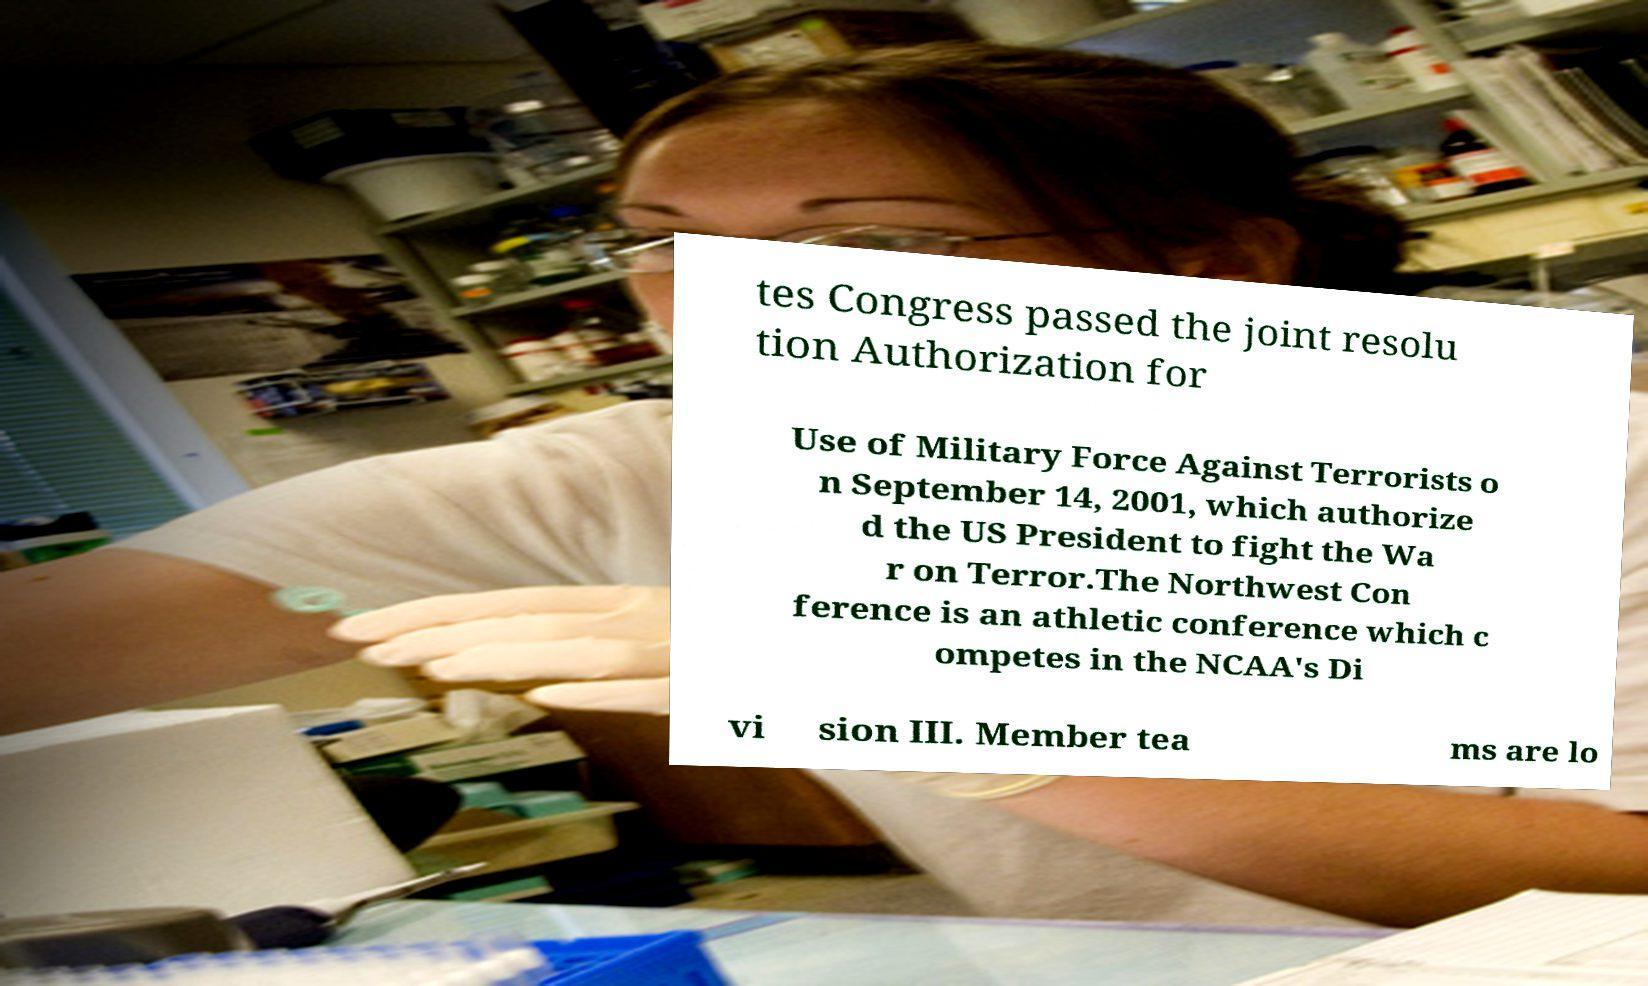Could you extract and type out the text from this image? tes Congress passed the joint resolu tion Authorization for Use of Military Force Against Terrorists o n September 14, 2001, which authorize d the US President to fight the Wa r on Terror.The Northwest Con ference is an athletic conference which c ompetes in the NCAA's Di vi sion III. Member tea ms are lo 